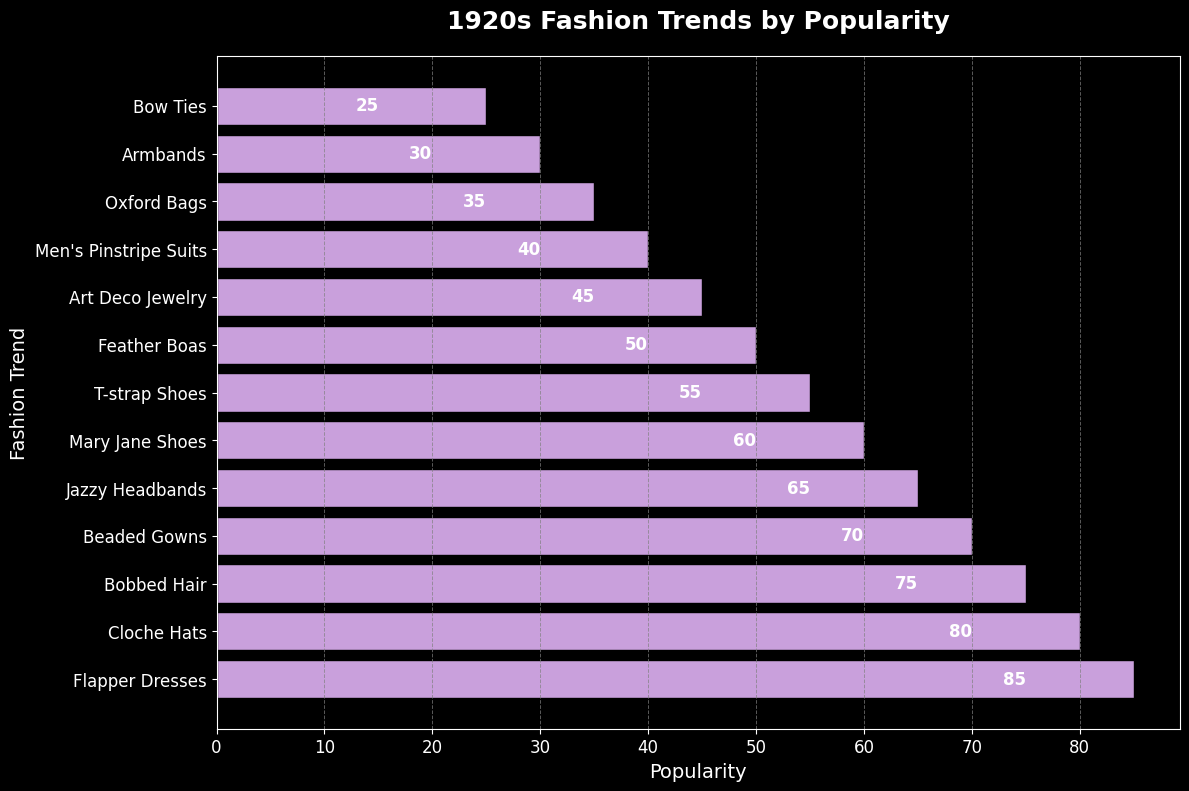Which fashion trend was the most popular in the 1920s? Look at the bar chart and identify the bar that reaches the highest point on the popularity axis.
Answer: Flapper Dresses Which was more popular, Cloche Hats or Bobbed Hair? Check the heights of the bars associated with Cloche Hats and Bobbed Hair, and compare their lengths.
Answer: Cloche Hats How much more popular were Flapper Dresses than Feather Boas? Determine the height of the Flapper Dresses' bar and subtract the height of the Feather Boas' bar from it. 85 - 50 = 35
Answer: 35 What is the combined popularity of Beaded Gowns and Mary Jane Shoes? Add the popularity values of Beaded Gowns (70) and Mary Jane Shoes (60). 70 + 60 = 130
Answer: 130 Which fashion trends have a popularity above 60? Identify the bars that have a height greater than 60. These are the trends with popularity ratings above 60.
Answer: Flapper Dresses, Cloche Hats, Bobbed Hair, Beaded Gowns, Jazzy Headbands Which fashion trend ranks fourth in popularity? Look at the bars in descending order of height and identify the fashion trend corresponding to the fourth highest bar.
Answer: Beaded Gowns How does the popularity of Oxford Bags compare to Men's Pinstripe Suits? Compare the heights of the bars for Oxford Bags and Men's Pinstripe Suits.
Answer: Oxford Bags are less popular What is the average popularity of the three least popular trends? Identify the lowest three bars and find their average by summing their heights and dividing by three. (Bow Ties 25 + Armbands 30 + Oxford Bags 35) / 3 = 30
Answer: 30 Which fashion trend stands out the most visually and why? Look for the bar with a different or unique attribute (color, length, height) that captures attention relative to others. Flapper Dresses is the tallest, making it stand out.
Answer: Flapper Dresses, due to its height How does the combined popularity of Jazzy Headbands and Feather Boas compare to the popularity of Cloche Hats? Sum the popularity values for Jazzy Headbands (65) and Feather Boas (50). Compare this sum to the popularity value of Cloche Hats (80). 65 + 50 = 115, which is greater than 80
Answer: Combined popularity 115 is greater than Cloche Hats 80 